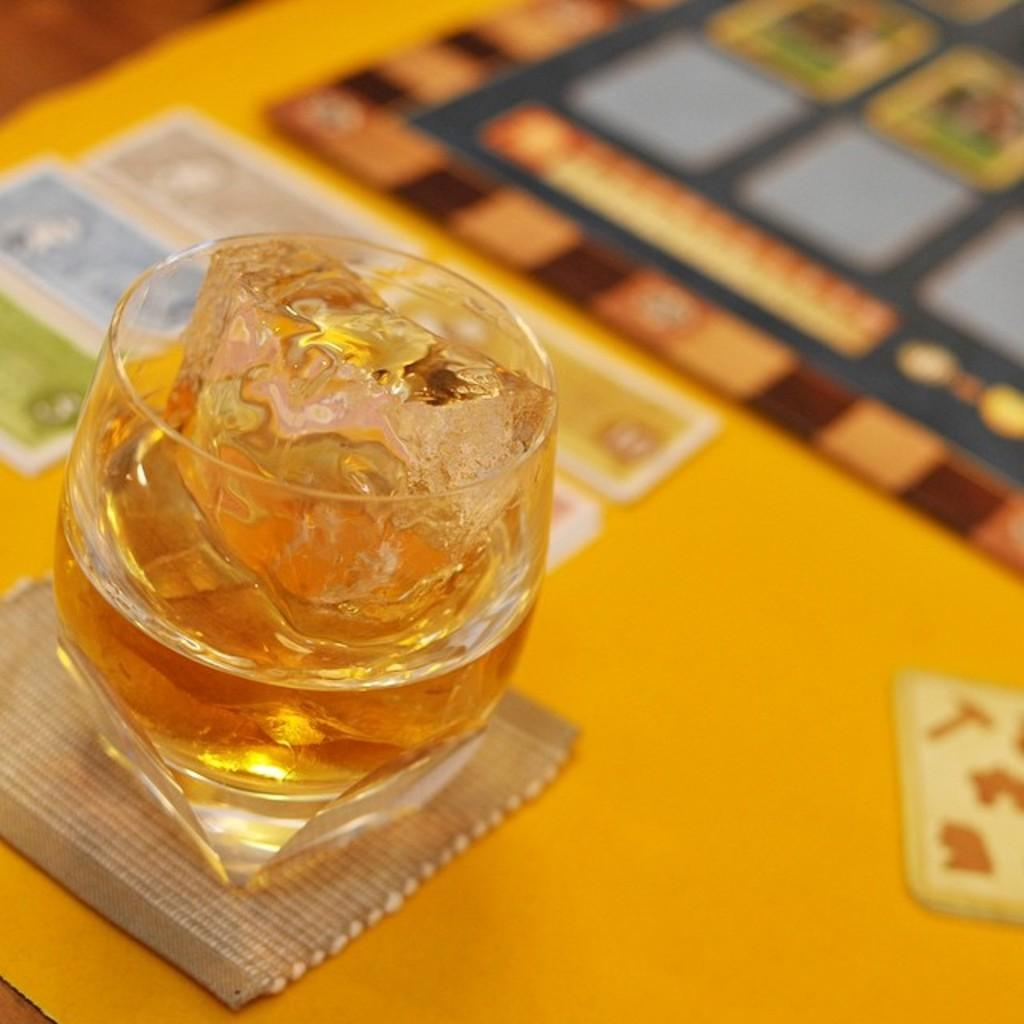What objects are on the table in the image? There are cards and a drink on the table. Can you describe the drink on the table? Unfortunately, the image does not provide enough detail to describe the drink. What might the cards be used for? The cards could be used for various purposes, such as playing a game or sorting information. What is the answer to the riddle on the cards in the image? There is no riddle present on the cards in the image. How does the development of the cards affect the sleep of the person in the image? There is no person present in the image, and therefore no information about their sleep can be inferred from the cards. 